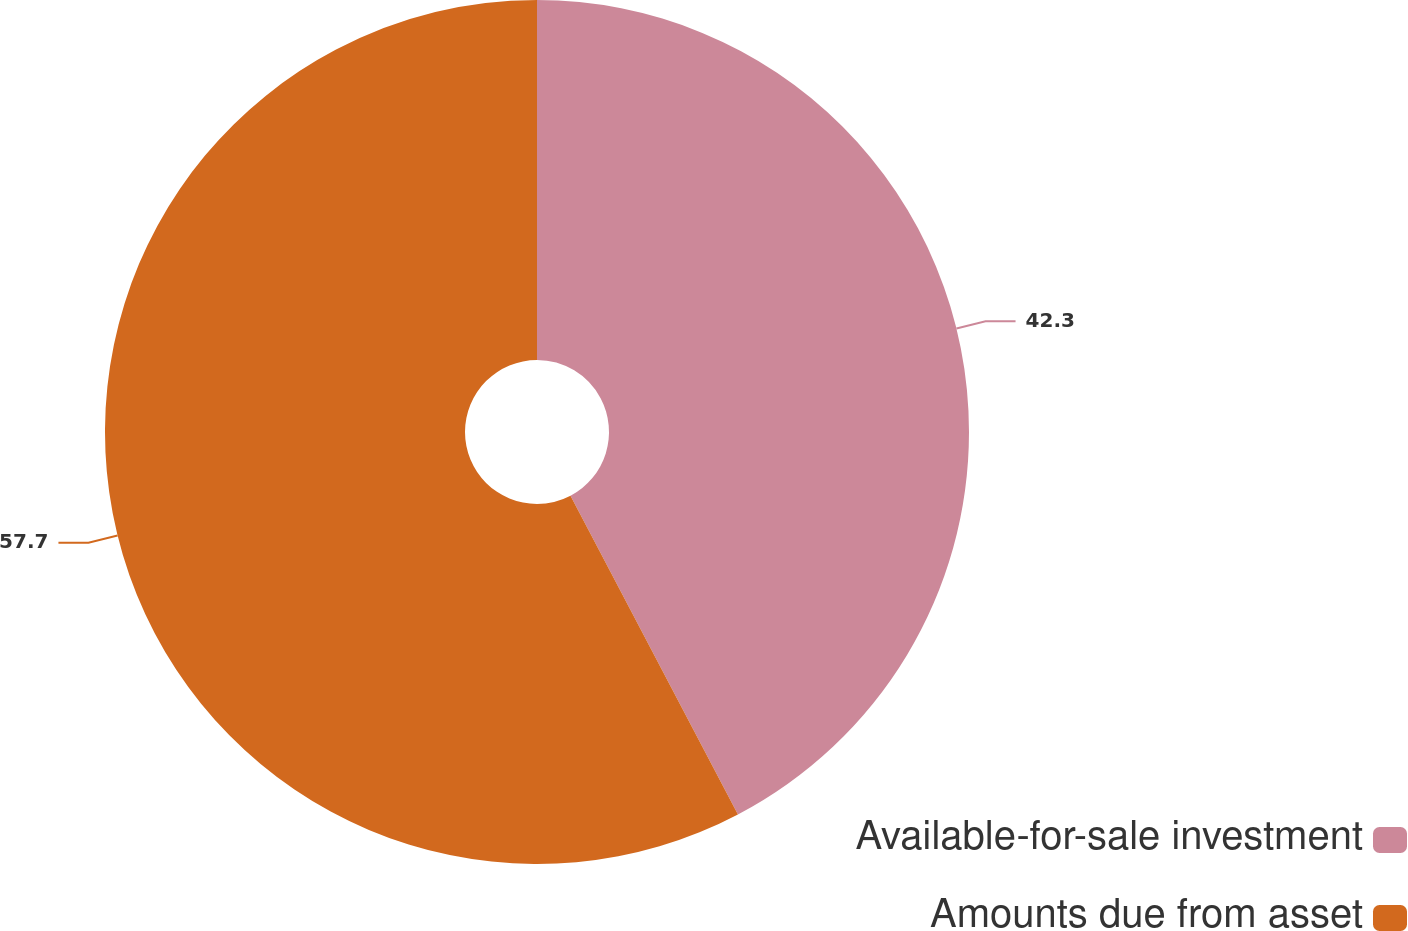<chart> <loc_0><loc_0><loc_500><loc_500><pie_chart><fcel>Available-for-sale investment<fcel>Amounts due from asset<nl><fcel>42.3%<fcel>57.7%<nl></chart> 